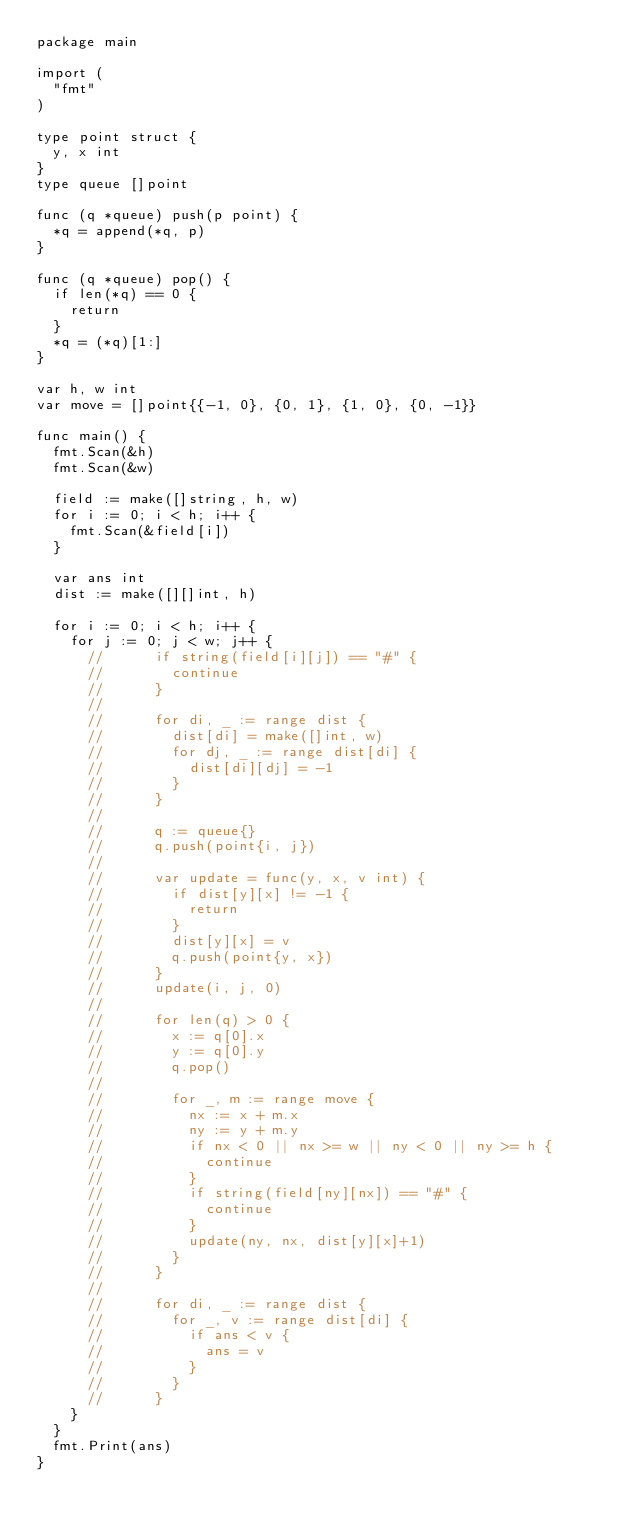<code> <loc_0><loc_0><loc_500><loc_500><_Go_>package main

import (
	"fmt"
)

type point struct {
	y, x int
}
type queue []point

func (q *queue) push(p point) {
	*q = append(*q, p)
}

func (q *queue) pop() {
	if len(*q) == 0 {
		return
	}
	*q = (*q)[1:]
}

var h, w int
var move = []point{{-1, 0}, {0, 1}, {1, 0}, {0, -1}}

func main() {
	fmt.Scan(&h)
	fmt.Scan(&w)

	field := make([]string, h, w)
	for i := 0; i < h; i++ {
		fmt.Scan(&field[i])
	}

	var ans int
	dist := make([][]int, h)

	for i := 0; i < h; i++ {
		for j := 0; j < w; j++ {
			//			if string(field[i][j]) == "#" {
			//				continue
			//			}
			//
			//			for di, _ := range dist {
			//				dist[di] = make([]int, w)
			//				for dj, _ := range dist[di] {
			//					dist[di][dj] = -1
			//				}
			//			}
			//
			//			q := queue{}
			//			q.push(point{i, j})
			//
			//			var update = func(y, x, v int) {
			//				if dist[y][x] != -1 {
			//					return
			//				}
			//				dist[y][x] = v
			//				q.push(point{y, x})
			//			}
			//			update(i, j, 0)
			//
			//			for len(q) > 0 {
			//				x := q[0].x
			//				y := q[0].y
			//				q.pop()
			//
			//				for _, m := range move {
			//					nx := x + m.x
			//					ny := y + m.y
			//					if nx < 0 || nx >= w || ny < 0 || ny >= h {
			//						continue
			//					}
			//					if string(field[ny][nx]) == "#" {
			//						continue
			//					}
			//					update(ny, nx, dist[y][x]+1)
			//				}
			//			}
			//
			//			for di, _ := range dist {
			//				for _, v := range dist[di] {
			//					if ans < v {
			//						ans = v
			//					}
			//				}
			//			}
		}
	}
	fmt.Print(ans)
}
</code> 